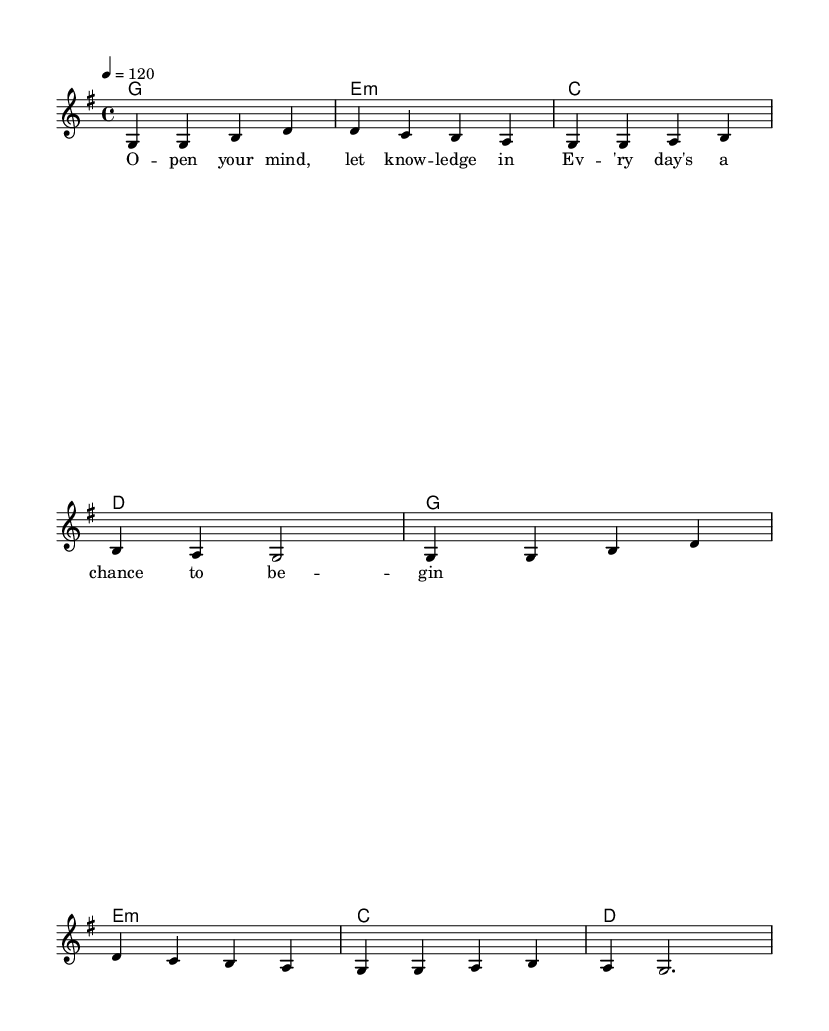What is the key signature of this music? The key signature is G major, which contains one sharp (F#). This can be identified at the beginning of the staff where the sharp is placed.
Answer: G major What is the time signature of this music? The time signature is 4/4, which means there are four beats per measure and a quarter note gets one beat. This is indicated at the beginning of the sheet music.
Answer: 4/4 What is the tempo marking of this music? The tempo marking is 120 beats per minute, indicated by the tempo line that specifies "4 = 120". This means the quarter note should be played at a rate of 120 beats each minute.
Answer: 120 How many measures are in the melody? The melody consists of 8 measures, as indicated by the groupings of the notes, where each group is separated by a vertical line (bar line).
Answer: 8 What is the first note of the melody? The first note of the melody is G, which can be seen at the start of the relative notation where the first note is explicitly notated.
Answer: G What is the last chord in the harmony? The last chord in the harmony is D major, which is the last chord listed in the chord progression under the chord names.
Answer: D How many distinct chords are used in the harmony? There are 3 distinct chords used in the harmony: G major, E minor, and C major. They are repeated throughout the piece, but only these three unique chords appear in the harmony section.
Answer: 3 